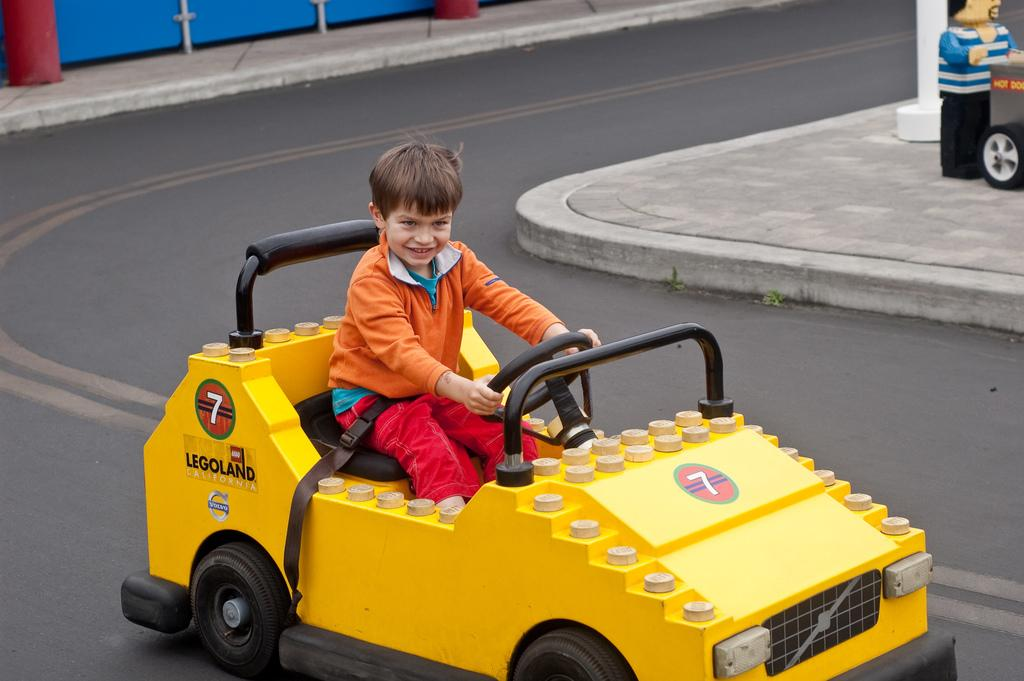What is the main subject of the image? There is a child in the image. What is the child doing in the image? The child is driving a vehicle. Where is the vehicle located in the image? The vehicle is on the road. What is the color of the vehicle? The color of the vehicle is yellow. What else can be seen on the right side of the image? There is a doll and a pole on the right side of the image. What is the taste of the salt in the image? There is no salt present in the image, so it is not possible to determine its taste. 